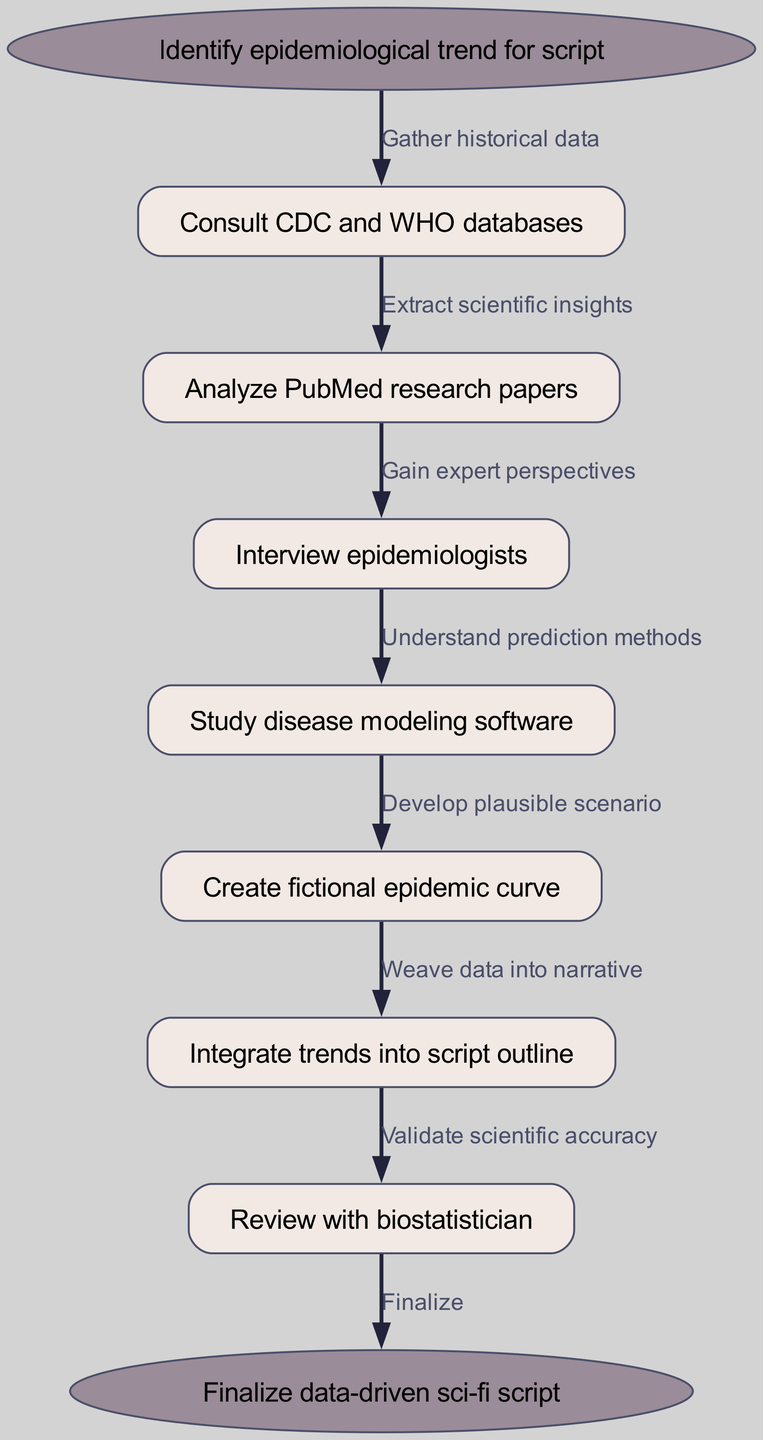What is the first step in the diagram? The diagram clearly states that the first step is to "Identify epidemiological trend for script." This is found at the starting node.
Answer: Identify epidemiological trend for script How many steps are there in total? By counting the number of nodes labeled as steps along with the start and end nodes, we find there are 7 steps (including the start and end nodes).
Answer: 7 What node directly follows "Consult CDC and WHO databases"? The node immediately following "Consult CDC and WHO databases" is "Analyze PubMed research papers." This is determined by following the flow of edges from the former to the latter.
Answer: Analyze PubMed research papers What is the final step mentioned in the diagram? The last step indicated in the flow is "Finalize data-driven sci-fi script," which represents the conclusion of the research process. This can be seen at the end node.
Answer: Finalize data-driven sci-fi script What type of data is gathered in the first step? The first step involves gathering "historical data," as described in the edge following the "Consult CDC and WHO databases" node.
Answer: Historical data Which node is connected to "Review with biostatistician"? The node "Integrate trends into script outline" is connected to "Review with biostatistician," as per the direction of the flow along the edges in the diagram.
Answer: Integrate trends into script outline What is the edge leading from the node "Study disease modeling software"? The edge leading from "Study disease modeling software" indicates the next action is to "Understand prediction methods," showing the flow of the research process.
Answer: Understand prediction methods What are the two main sources of data mentioned in the steps? The two main sources of data referenced are "CDC and WHO databases" and "PubMed research papers," which are highlighted in separate nodes within the process.
Answer: CDC and WHO databases, PubMed research papers What is the overall purpose depicted in this flow chart? The overall purpose is to develop a "data-driven sci-fi script" by following a systematic research process that incorporates epidemiological trends into the narrative.
Answer: Data-driven sci-fi script 